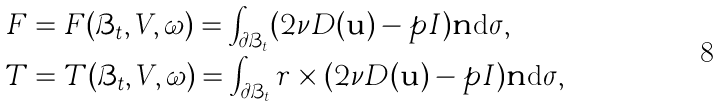<formula> <loc_0><loc_0><loc_500><loc_500>F & = F ( \mathcal { B } _ { t } , V , \omega ) = \int _ { \partial \mathcal { B } _ { t } } ( 2 \nu D ( \mathbf u ) - p I ) \mathbf n \text {d$\sigma$} , \\ T & = T ( \mathcal { B } _ { t } , V , \omega ) = \int _ { \partial \mathcal { B } _ { t } } r \times ( 2 \nu D ( \mathbf u ) - p I ) \mathbf n \text {d$\sigma$} ,</formula> 